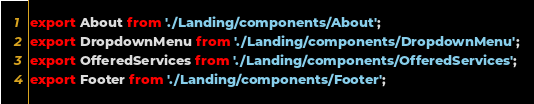Convert code to text. <code><loc_0><loc_0><loc_500><loc_500><_JavaScript_>export About from './Landing/components/About';
export DropdownMenu from './Landing/components/DropdownMenu';
export OfferedServices from './Landing/components/OfferedServices';
export Footer from './Landing/components/Footer';
</code> 